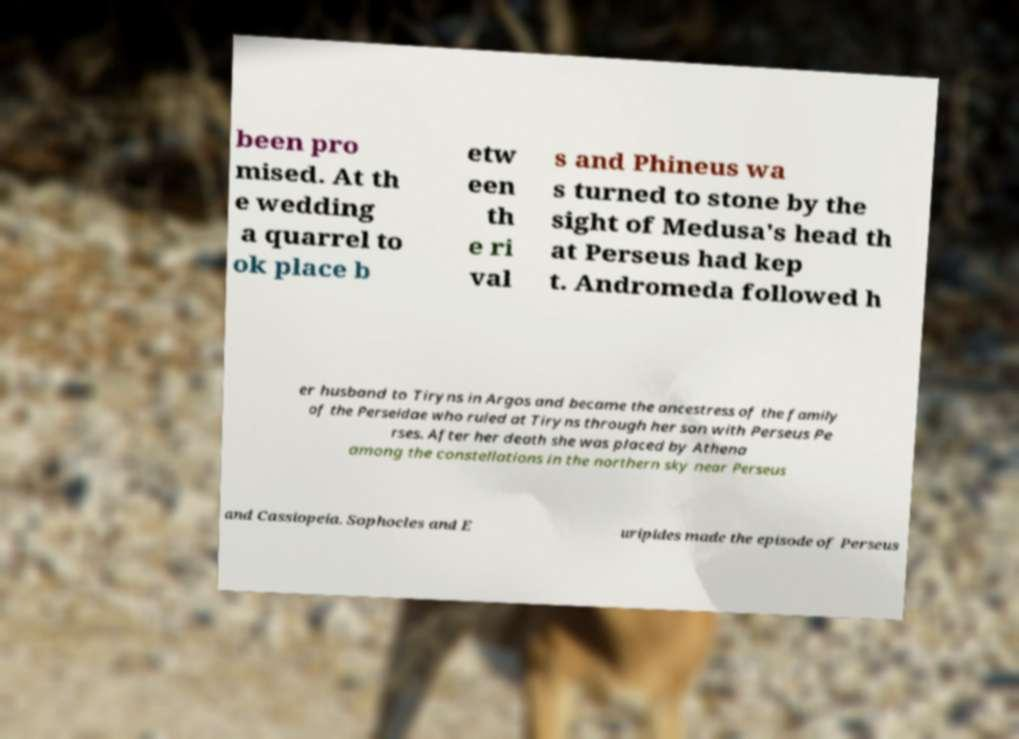Can you read and provide the text displayed in the image?This photo seems to have some interesting text. Can you extract and type it out for me? been pro mised. At th e wedding a quarrel to ok place b etw een th e ri val s and Phineus wa s turned to stone by the sight of Medusa's head th at Perseus had kep t. Andromeda followed h er husband to Tiryns in Argos and became the ancestress of the family of the Perseidae who ruled at Tiryns through her son with Perseus Pe rses. After her death she was placed by Athena among the constellations in the northern sky near Perseus and Cassiopeia. Sophocles and E uripides made the episode of Perseus 